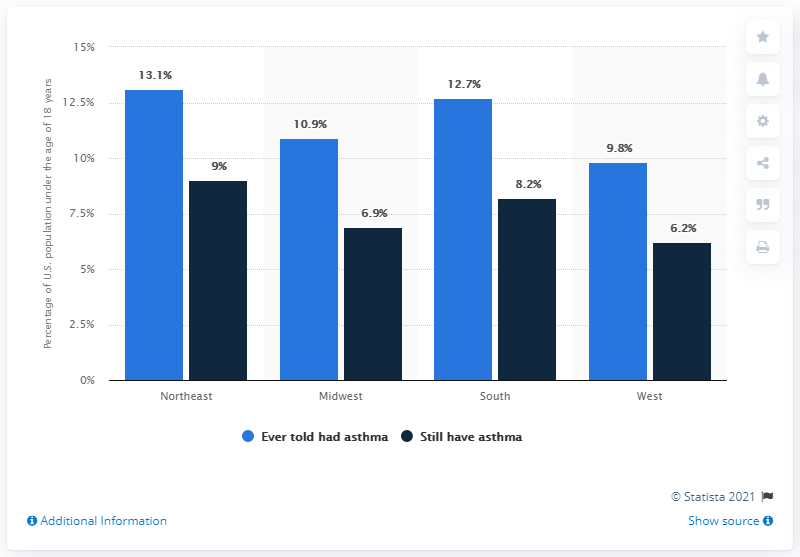Mention a couple of crucial points in this snapshot. The chart provides the percentage of a number and its next percentage, starting from 9%, followed by 6.9%, 8.2%, and 6.2%. The average of the blue bar data is approximately 11.625. 